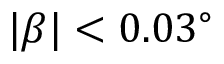Convert formula to latex. <formula><loc_0><loc_0><loc_500><loc_500>| \beta | < 0 . 0 3 ^ { \circ }</formula> 